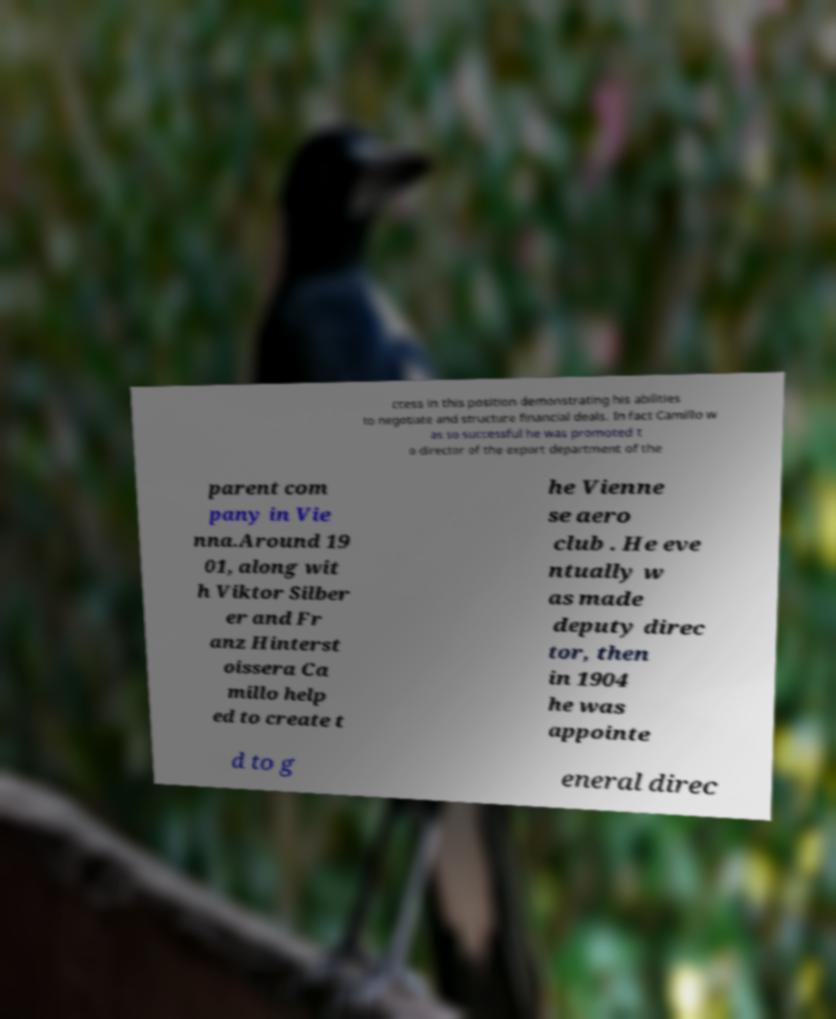What messages or text are displayed in this image? I need them in a readable, typed format. ccess in this position demonstrating his abilities to negotiate and structure financial deals. In fact Camillo w as so successful he was promoted t o director of the export department of the parent com pany in Vie nna.Around 19 01, along wit h Viktor Silber er and Fr anz Hinterst oissera Ca millo help ed to create t he Vienne se aero club . He eve ntually w as made deputy direc tor, then in 1904 he was appointe d to g eneral direc 